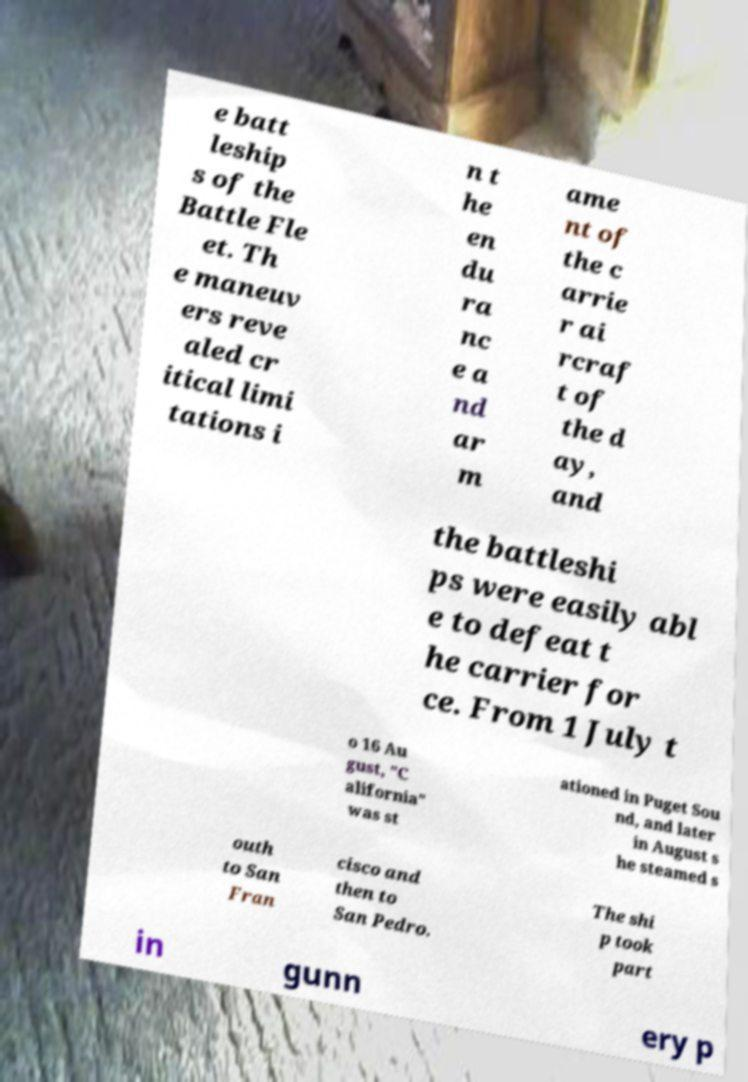For documentation purposes, I need the text within this image transcribed. Could you provide that? e batt leship s of the Battle Fle et. Th e maneuv ers reve aled cr itical limi tations i n t he en du ra nc e a nd ar m ame nt of the c arrie r ai rcraf t of the d ay, and the battleshi ps were easily abl e to defeat t he carrier for ce. From 1 July t o 16 Au gust, "C alifornia" was st ationed in Puget Sou nd, and later in August s he steamed s outh to San Fran cisco and then to San Pedro. The shi p took part in gunn ery p 